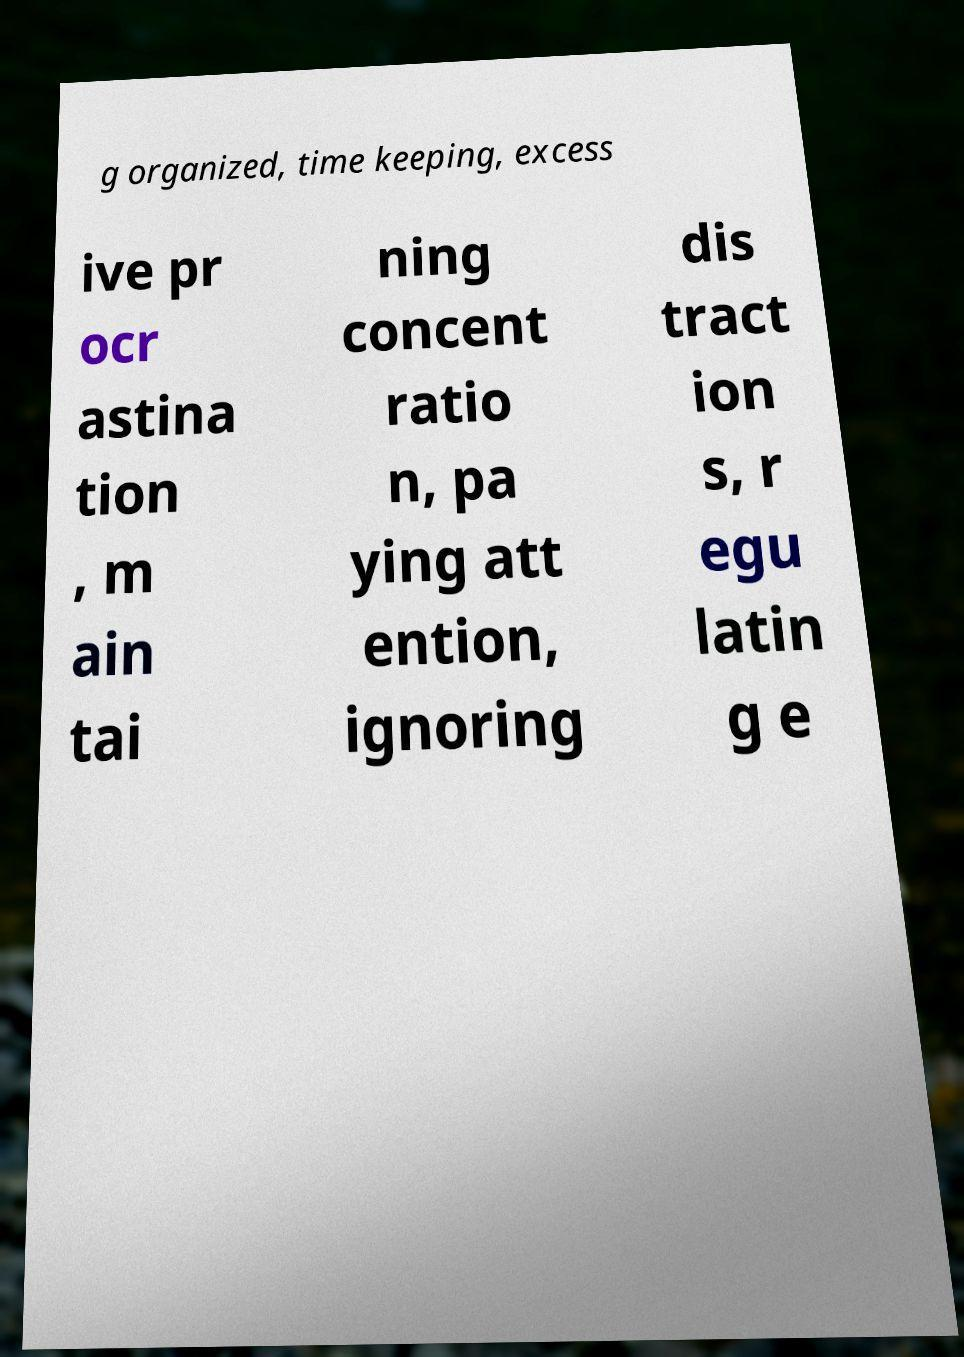Please read and relay the text visible in this image. What does it say? g organized, time keeping, excess ive pr ocr astina tion , m ain tai ning concent ratio n, pa ying att ention, ignoring dis tract ion s, r egu latin g e 